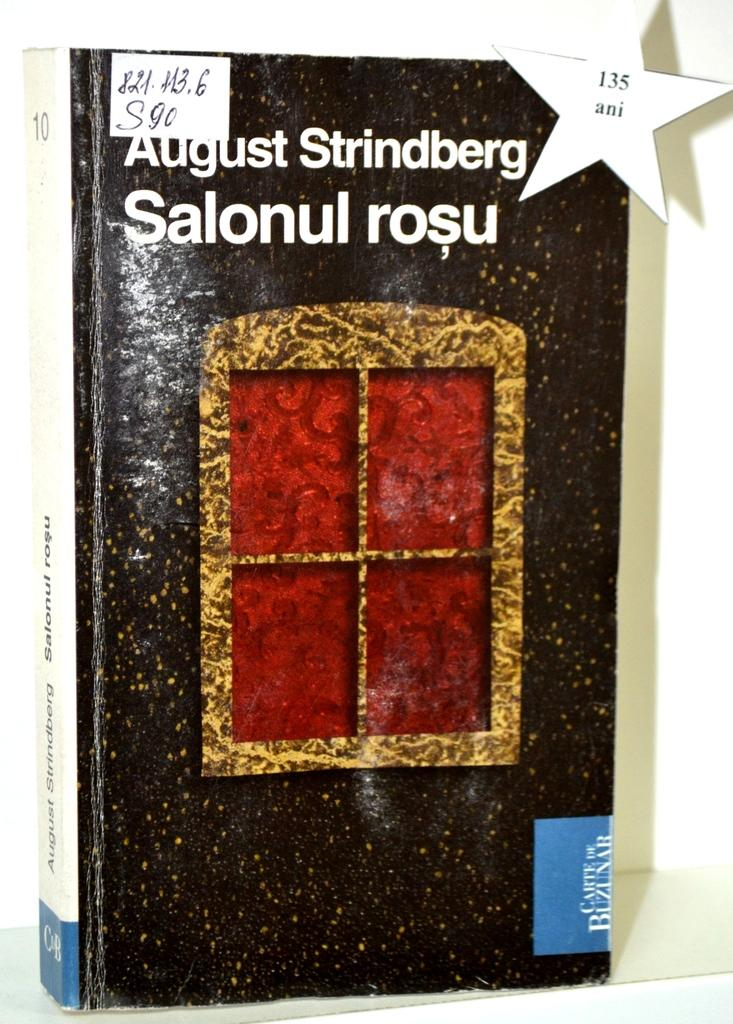<image>
Summarize the visual content of the image. a book that has the month of August on it 